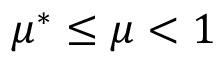<formula> <loc_0><loc_0><loc_500><loc_500>\mu ^ { * } \leq \mu < 1</formula> 